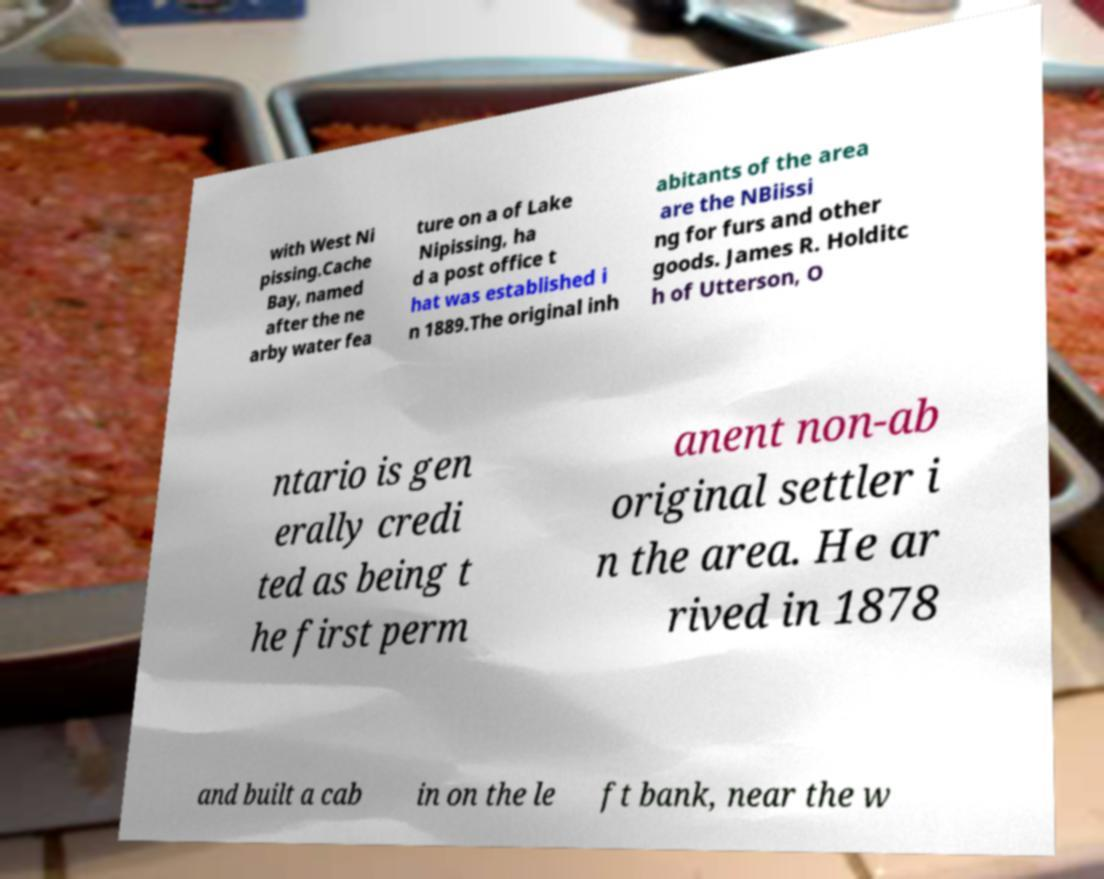Please read and relay the text visible in this image. What does it say? The text on the image discusses some aspects of Cache Bay, which is located near Lake Nipissing. It mentions that Cache Bay had a post office established in 1889 and references historical figures such as James R. Holditch, who is credited as the first permanent non-aboriginal settler in the area, arriving in 1878. The document also notes that the original inhabitants of the area were Nibiissing, who traded furs and other goods. 